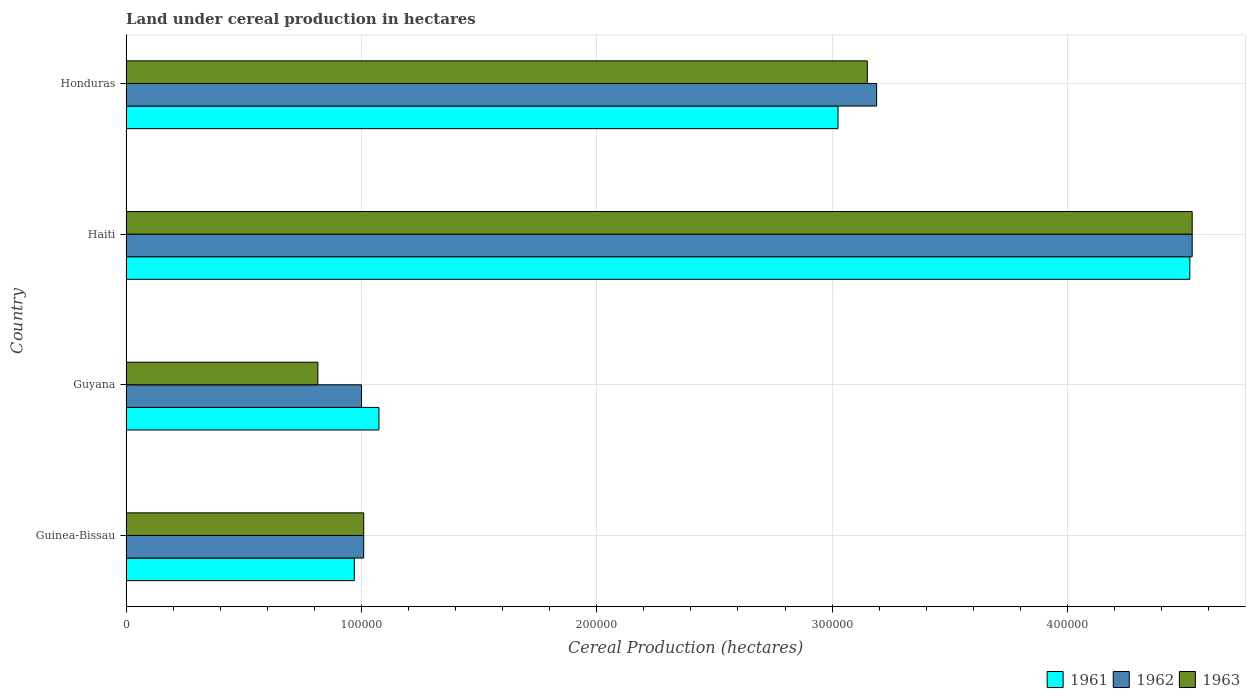How many different coloured bars are there?
Ensure brevity in your answer.  3. What is the label of the 3rd group of bars from the top?
Offer a very short reply. Guyana. What is the land under cereal production in 1962 in Guyana?
Make the answer very short. 1.00e+05. Across all countries, what is the maximum land under cereal production in 1961?
Offer a very short reply. 4.52e+05. Across all countries, what is the minimum land under cereal production in 1963?
Your answer should be compact. 8.15e+04. In which country was the land under cereal production in 1962 maximum?
Give a very brief answer. Haiti. In which country was the land under cereal production in 1961 minimum?
Keep it short and to the point. Guinea-Bissau. What is the total land under cereal production in 1963 in the graph?
Your response must be concise. 9.50e+05. What is the difference between the land under cereal production in 1963 in Guyana and that in Haiti?
Offer a very short reply. -3.71e+05. What is the difference between the land under cereal production in 1963 in Honduras and the land under cereal production in 1961 in Haiti?
Your response must be concise. -1.37e+05. What is the average land under cereal production in 1963 per country?
Ensure brevity in your answer.  2.38e+05. In how many countries, is the land under cereal production in 1962 greater than 80000 hectares?
Provide a short and direct response. 4. What is the ratio of the land under cereal production in 1961 in Guinea-Bissau to that in Guyana?
Provide a succinct answer. 0.9. Is the land under cereal production in 1962 in Guinea-Bissau less than that in Guyana?
Your answer should be compact. No. What is the difference between the highest and the second highest land under cereal production in 1962?
Offer a very short reply. 1.34e+05. What is the difference between the highest and the lowest land under cereal production in 1962?
Provide a short and direct response. 3.53e+05. Is it the case that in every country, the sum of the land under cereal production in 1961 and land under cereal production in 1962 is greater than the land under cereal production in 1963?
Make the answer very short. Yes. Are all the bars in the graph horizontal?
Your answer should be very brief. Yes. Does the graph contain grids?
Your response must be concise. Yes. Where does the legend appear in the graph?
Provide a short and direct response. Bottom right. How are the legend labels stacked?
Provide a succinct answer. Horizontal. What is the title of the graph?
Your response must be concise. Land under cereal production in hectares. What is the label or title of the X-axis?
Your answer should be compact. Cereal Production (hectares). What is the label or title of the Y-axis?
Make the answer very short. Country. What is the Cereal Production (hectares) of 1961 in Guinea-Bissau?
Give a very brief answer. 9.70e+04. What is the Cereal Production (hectares) in 1962 in Guinea-Bissau?
Provide a short and direct response. 1.01e+05. What is the Cereal Production (hectares) of 1963 in Guinea-Bissau?
Make the answer very short. 1.01e+05. What is the Cereal Production (hectares) in 1961 in Guyana?
Provide a short and direct response. 1.07e+05. What is the Cereal Production (hectares) in 1962 in Guyana?
Offer a terse response. 1.00e+05. What is the Cereal Production (hectares) in 1963 in Guyana?
Your response must be concise. 8.15e+04. What is the Cereal Production (hectares) in 1961 in Haiti?
Give a very brief answer. 4.52e+05. What is the Cereal Production (hectares) of 1962 in Haiti?
Keep it short and to the point. 4.53e+05. What is the Cereal Production (hectares) of 1963 in Haiti?
Make the answer very short. 4.53e+05. What is the Cereal Production (hectares) of 1961 in Honduras?
Give a very brief answer. 3.03e+05. What is the Cereal Production (hectares) of 1962 in Honduras?
Your answer should be compact. 3.19e+05. What is the Cereal Production (hectares) of 1963 in Honduras?
Ensure brevity in your answer.  3.15e+05. Across all countries, what is the maximum Cereal Production (hectares) in 1961?
Give a very brief answer. 4.52e+05. Across all countries, what is the maximum Cereal Production (hectares) of 1962?
Give a very brief answer. 4.53e+05. Across all countries, what is the maximum Cereal Production (hectares) of 1963?
Provide a short and direct response. 4.53e+05. Across all countries, what is the minimum Cereal Production (hectares) in 1961?
Ensure brevity in your answer.  9.70e+04. Across all countries, what is the minimum Cereal Production (hectares) in 1962?
Make the answer very short. 1.00e+05. Across all countries, what is the minimum Cereal Production (hectares) of 1963?
Provide a short and direct response. 8.15e+04. What is the total Cereal Production (hectares) in 1961 in the graph?
Make the answer very short. 9.59e+05. What is the total Cereal Production (hectares) in 1962 in the graph?
Ensure brevity in your answer.  9.73e+05. What is the total Cereal Production (hectares) in 1963 in the graph?
Offer a terse response. 9.50e+05. What is the difference between the Cereal Production (hectares) of 1961 in Guinea-Bissau and that in Guyana?
Your response must be concise. -1.05e+04. What is the difference between the Cereal Production (hectares) of 1962 in Guinea-Bissau and that in Guyana?
Provide a succinct answer. 940. What is the difference between the Cereal Production (hectares) in 1963 in Guinea-Bissau and that in Guyana?
Provide a succinct answer. 1.95e+04. What is the difference between the Cereal Production (hectares) in 1961 in Guinea-Bissau and that in Haiti?
Give a very brief answer. -3.55e+05. What is the difference between the Cereal Production (hectares) in 1962 in Guinea-Bissau and that in Haiti?
Give a very brief answer. -3.52e+05. What is the difference between the Cereal Production (hectares) of 1963 in Guinea-Bissau and that in Haiti?
Offer a very short reply. -3.52e+05. What is the difference between the Cereal Production (hectares) of 1961 in Guinea-Bissau and that in Honduras?
Your response must be concise. -2.06e+05. What is the difference between the Cereal Production (hectares) in 1962 in Guinea-Bissau and that in Honduras?
Offer a terse response. -2.18e+05. What is the difference between the Cereal Production (hectares) in 1963 in Guinea-Bissau and that in Honduras?
Provide a succinct answer. -2.14e+05. What is the difference between the Cereal Production (hectares) in 1961 in Guyana and that in Haiti?
Give a very brief answer. -3.45e+05. What is the difference between the Cereal Production (hectares) of 1962 in Guyana and that in Haiti?
Give a very brief answer. -3.53e+05. What is the difference between the Cereal Production (hectares) in 1963 in Guyana and that in Haiti?
Ensure brevity in your answer.  -3.71e+05. What is the difference between the Cereal Production (hectares) in 1961 in Guyana and that in Honduras?
Your response must be concise. -1.95e+05. What is the difference between the Cereal Production (hectares) of 1962 in Guyana and that in Honduras?
Ensure brevity in your answer.  -2.19e+05. What is the difference between the Cereal Production (hectares) of 1963 in Guyana and that in Honduras?
Give a very brief answer. -2.33e+05. What is the difference between the Cereal Production (hectares) of 1961 in Haiti and that in Honduras?
Offer a terse response. 1.49e+05. What is the difference between the Cereal Production (hectares) of 1962 in Haiti and that in Honduras?
Keep it short and to the point. 1.34e+05. What is the difference between the Cereal Production (hectares) in 1963 in Haiti and that in Honduras?
Provide a short and direct response. 1.38e+05. What is the difference between the Cereal Production (hectares) of 1961 in Guinea-Bissau and the Cereal Production (hectares) of 1962 in Guyana?
Your answer should be compact. -3060. What is the difference between the Cereal Production (hectares) of 1961 in Guinea-Bissau and the Cereal Production (hectares) of 1963 in Guyana?
Give a very brief answer. 1.55e+04. What is the difference between the Cereal Production (hectares) of 1962 in Guinea-Bissau and the Cereal Production (hectares) of 1963 in Guyana?
Offer a very short reply. 1.95e+04. What is the difference between the Cereal Production (hectares) of 1961 in Guinea-Bissau and the Cereal Production (hectares) of 1962 in Haiti?
Offer a very short reply. -3.56e+05. What is the difference between the Cereal Production (hectares) of 1961 in Guinea-Bissau and the Cereal Production (hectares) of 1963 in Haiti?
Your answer should be very brief. -3.56e+05. What is the difference between the Cereal Production (hectares) in 1962 in Guinea-Bissau and the Cereal Production (hectares) in 1963 in Haiti?
Provide a short and direct response. -3.52e+05. What is the difference between the Cereal Production (hectares) in 1961 in Guinea-Bissau and the Cereal Production (hectares) in 1962 in Honduras?
Give a very brief answer. -2.22e+05. What is the difference between the Cereal Production (hectares) in 1961 in Guinea-Bissau and the Cereal Production (hectares) in 1963 in Honduras?
Your answer should be very brief. -2.18e+05. What is the difference between the Cereal Production (hectares) in 1962 in Guinea-Bissau and the Cereal Production (hectares) in 1963 in Honduras?
Your response must be concise. -2.14e+05. What is the difference between the Cereal Production (hectares) in 1961 in Guyana and the Cereal Production (hectares) in 1962 in Haiti?
Provide a short and direct response. -3.46e+05. What is the difference between the Cereal Production (hectares) in 1961 in Guyana and the Cereal Production (hectares) in 1963 in Haiti?
Offer a very short reply. -3.46e+05. What is the difference between the Cereal Production (hectares) of 1962 in Guyana and the Cereal Production (hectares) of 1963 in Haiti?
Your answer should be compact. -3.53e+05. What is the difference between the Cereal Production (hectares) of 1961 in Guyana and the Cereal Production (hectares) of 1962 in Honduras?
Ensure brevity in your answer.  -2.11e+05. What is the difference between the Cereal Production (hectares) in 1961 in Guyana and the Cereal Production (hectares) in 1963 in Honduras?
Provide a short and direct response. -2.08e+05. What is the difference between the Cereal Production (hectares) of 1962 in Guyana and the Cereal Production (hectares) of 1963 in Honduras?
Provide a short and direct response. -2.15e+05. What is the difference between the Cereal Production (hectares) of 1961 in Haiti and the Cereal Production (hectares) of 1962 in Honduras?
Give a very brief answer. 1.33e+05. What is the difference between the Cereal Production (hectares) of 1961 in Haiti and the Cereal Production (hectares) of 1963 in Honduras?
Your answer should be very brief. 1.37e+05. What is the difference between the Cereal Production (hectares) of 1962 in Haiti and the Cereal Production (hectares) of 1963 in Honduras?
Your answer should be very brief. 1.38e+05. What is the average Cereal Production (hectares) in 1961 per country?
Make the answer very short. 2.40e+05. What is the average Cereal Production (hectares) of 1962 per country?
Offer a very short reply. 2.43e+05. What is the average Cereal Production (hectares) in 1963 per country?
Your answer should be compact. 2.38e+05. What is the difference between the Cereal Production (hectares) in 1961 and Cereal Production (hectares) in 1962 in Guinea-Bissau?
Offer a terse response. -4000. What is the difference between the Cereal Production (hectares) of 1961 and Cereal Production (hectares) of 1963 in Guinea-Bissau?
Your response must be concise. -4000. What is the difference between the Cereal Production (hectares) of 1961 and Cereal Production (hectares) of 1962 in Guyana?
Your answer should be very brief. 7401. What is the difference between the Cereal Production (hectares) of 1961 and Cereal Production (hectares) of 1963 in Guyana?
Give a very brief answer. 2.59e+04. What is the difference between the Cereal Production (hectares) of 1962 and Cereal Production (hectares) of 1963 in Guyana?
Offer a very short reply. 1.85e+04. What is the difference between the Cereal Production (hectares) in 1961 and Cereal Production (hectares) in 1962 in Haiti?
Provide a succinct answer. -1000. What is the difference between the Cereal Production (hectares) in 1961 and Cereal Production (hectares) in 1963 in Haiti?
Give a very brief answer. -1000. What is the difference between the Cereal Production (hectares) in 1961 and Cereal Production (hectares) in 1962 in Honduras?
Offer a terse response. -1.64e+04. What is the difference between the Cereal Production (hectares) in 1961 and Cereal Production (hectares) in 1963 in Honduras?
Your answer should be compact. -1.24e+04. What is the difference between the Cereal Production (hectares) of 1962 and Cereal Production (hectares) of 1963 in Honduras?
Provide a short and direct response. 3957. What is the ratio of the Cereal Production (hectares) of 1961 in Guinea-Bissau to that in Guyana?
Your answer should be very brief. 0.9. What is the ratio of the Cereal Production (hectares) of 1962 in Guinea-Bissau to that in Guyana?
Make the answer very short. 1.01. What is the ratio of the Cereal Production (hectares) in 1963 in Guinea-Bissau to that in Guyana?
Provide a succinct answer. 1.24. What is the ratio of the Cereal Production (hectares) in 1961 in Guinea-Bissau to that in Haiti?
Make the answer very short. 0.21. What is the ratio of the Cereal Production (hectares) in 1962 in Guinea-Bissau to that in Haiti?
Offer a very short reply. 0.22. What is the ratio of the Cereal Production (hectares) of 1963 in Guinea-Bissau to that in Haiti?
Offer a very short reply. 0.22. What is the ratio of the Cereal Production (hectares) of 1961 in Guinea-Bissau to that in Honduras?
Offer a terse response. 0.32. What is the ratio of the Cereal Production (hectares) of 1962 in Guinea-Bissau to that in Honduras?
Offer a very short reply. 0.32. What is the ratio of the Cereal Production (hectares) in 1963 in Guinea-Bissau to that in Honduras?
Offer a terse response. 0.32. What is the ratio of the Cereal Production (hectares) in 1961 in Guyana to that in Haiti?
Offer a terse response. 0.24. What is the ratio of the Cereal Production (hectares) in 1962 in Guyana to that in Haiti?
Your response must be concise. 0.22. What is the ratio of the Cereal Production (hectares) in 1963 in Guyana to that in Haiti?
Your answer should be very brief. 0.18. What is the ratio of the Cereal Production (hectares) of 1961 in Guyana to that in Honduras?
Your response must be concise. 0.36. What is the ratio of the Cereal Production (hectares) of 1962 in Guyana to that in Honduras?
Make the answer very short. 0.31. What is the ratio of the Cereal Production (hectares) in 1963 in Guyana to that in Honduras?
Ensure brevity in your answer.  0.26. What is the ratio of the Cereal Production (hectares) of 1961 in Haiti to that in Honduras?
Provide a succinct answer. 1.49. What is the ratio of the Cereal Production (hectares) of 1962 in Haiti to that in Honduras?
Keep it short and to the point. 1.42. What is the ratio of the Cereal Production (hectares) in 1963 in Haiti to that in Honduras?
Your answer should be compact. 1.44. What is the difference between the highest and the second highest Cereal Production (hectares) in 1961?
Ensure brevity in your answer.  1.49e+05. What is the difference between the highest and the second highest Cereal Production (hectares) of 1962?
Your answer should be compact. 1.34e+05. What is the difference between the highest and the second highest Cereal Production (hectares) of 1963?
Ensure brevity in your answer.  1.38e+05. What is the difference between the highest and the lowest Cereal Production (hectares) of 1961?
Give a very brief answer. 3.55e+05. What is the difference between the highest and the lowest Cereal Production (hectares) in 1962?
Keep it short and to the point. 3.53e+05. What is the difference between the highest and the lowest Cereal Production (hectares) of 1963?
Your response must be concise. 3.71e+05. 